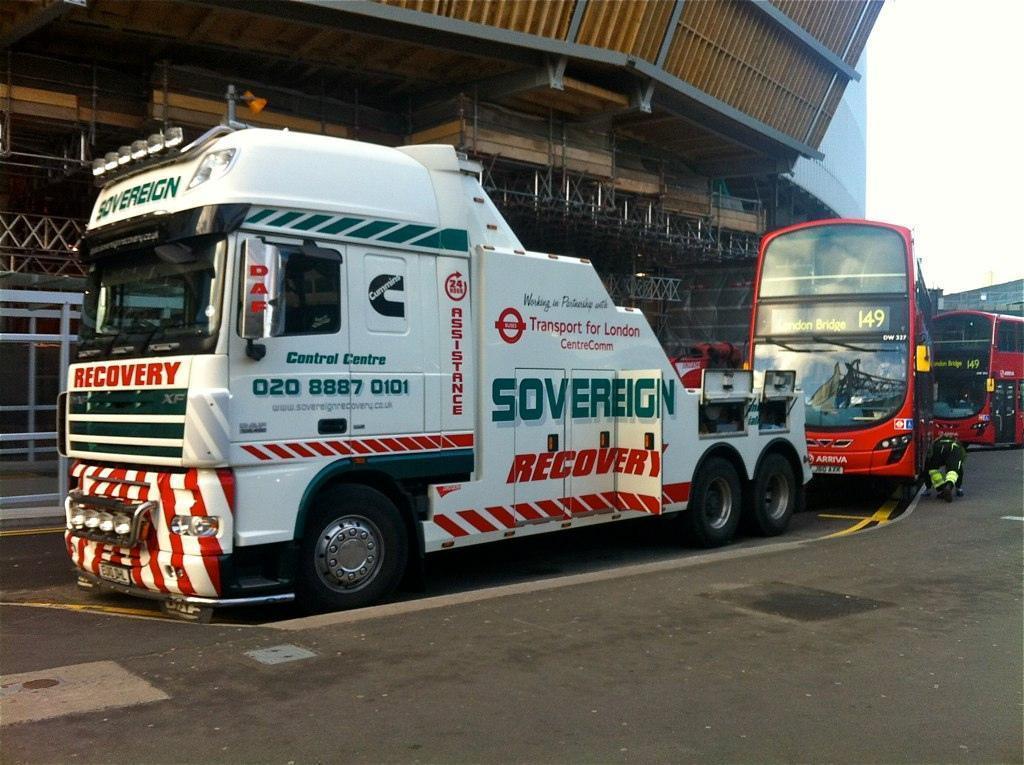How many decks are on the bus?
Give a very brief answer. 2. How many vehicles are parked?
Give a very brief answer. 3. How many wheels are shown on the truck?
Give a very brief answer. 3. How many busses are in the picture?
Give a very brief answer. 2. 